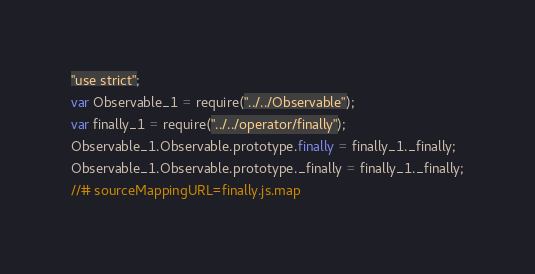<code> <loc_0><loc_0><loc_500><loc_500><_JavaScript_>"use strict";
var Observable_1 = require("../../Observable");
var finally_1 = require("../../operator/finally");
Observable_1.Observable.prototype.finally = finally_1._finally;
Observable_1.Observable.prototype._finally = finally_1._finally;
//# sourceMappingURL=finally.js.map</code> 